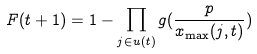<formula> <loc_0><loc_0><loc_500><loc_500>F ( t + 1 ) = 1 - \prod _ { j \in { u } ( t ) } g ( \frac { p } { x _ { \max } ( j , t ) } )</formula> 